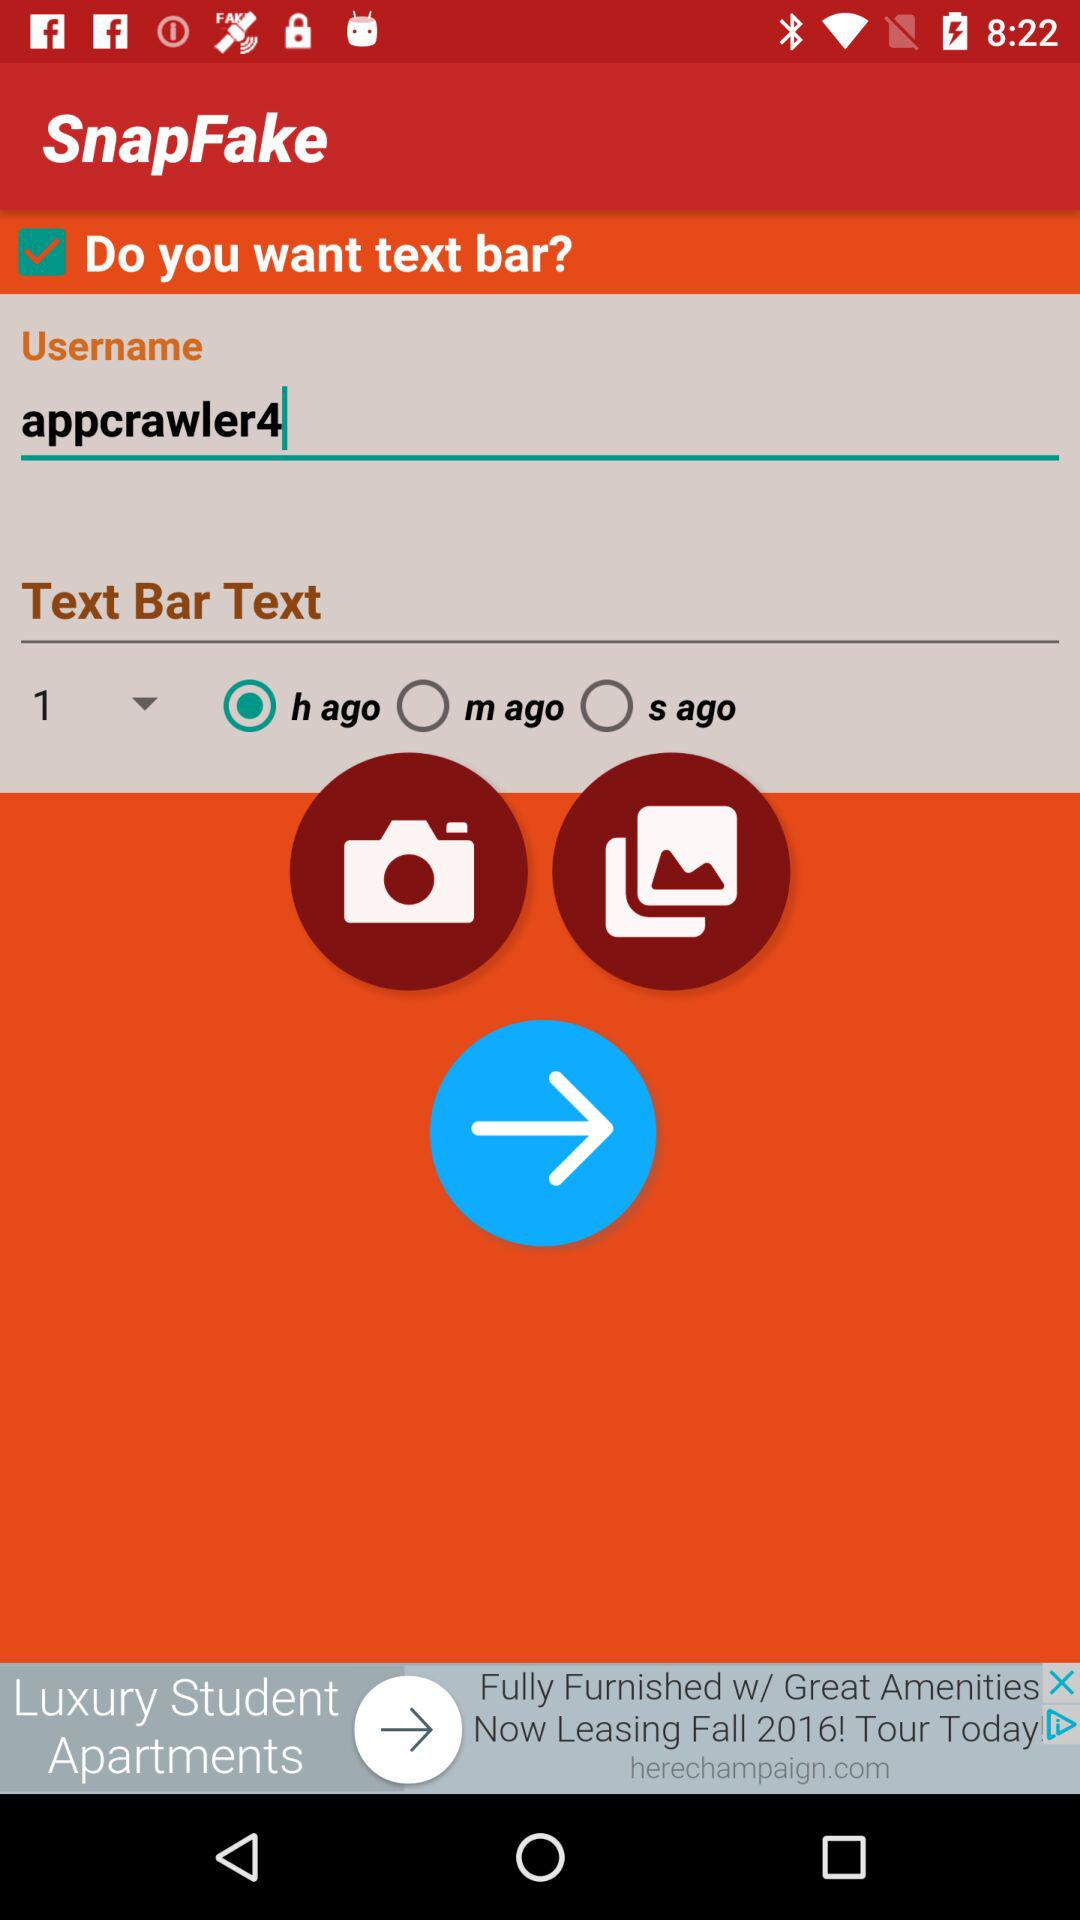Which option is selected? The selected option is "h ago". 